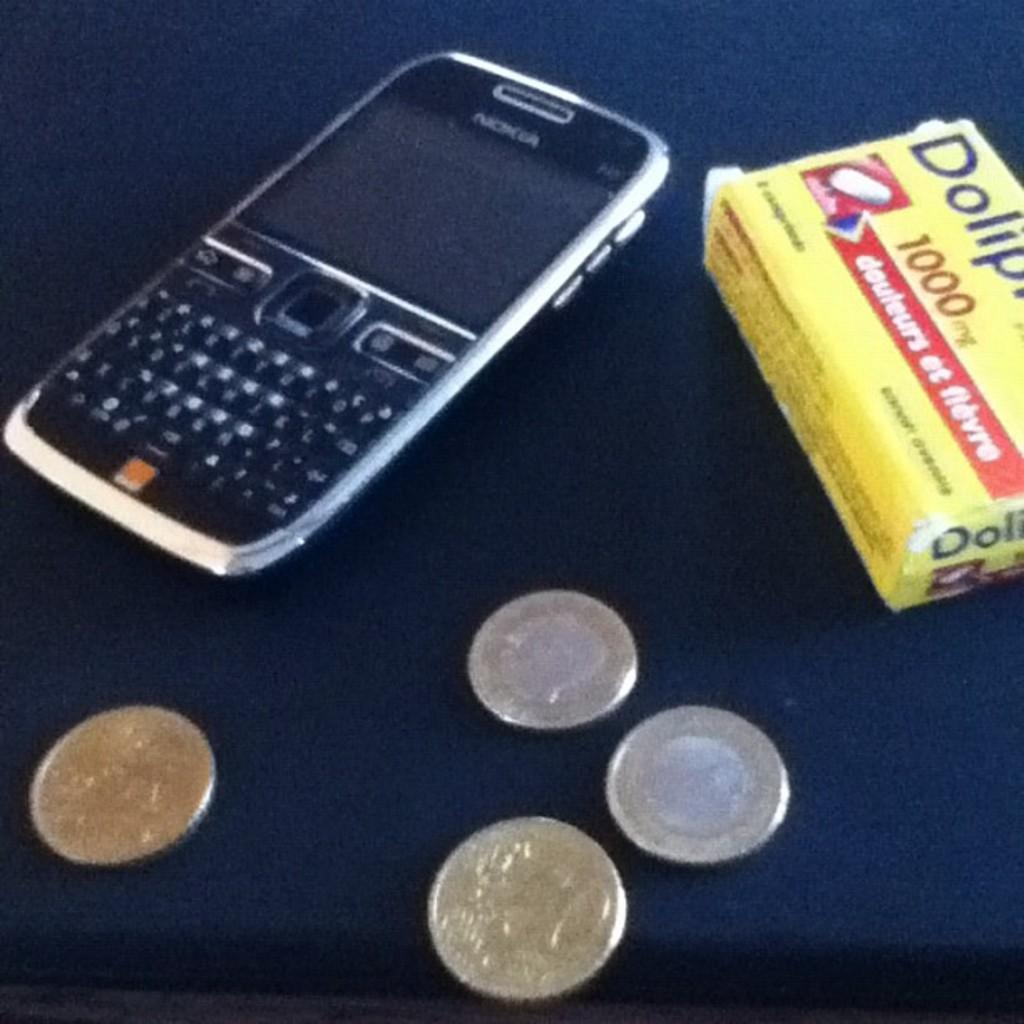<image>
Share a concise interpretation of the image provided. A Nokia cell phone sits on a table next to a box for a 1000 milligram pain reliever. 